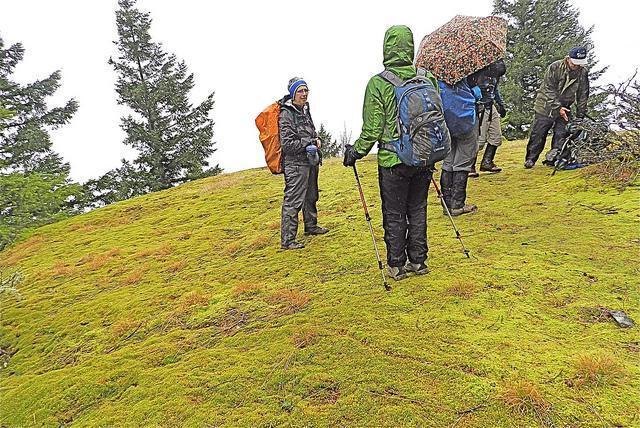How many people are in the photo?
Give a very brief answer. 5. How many people are visible?
Give a very brief answer. 5. 